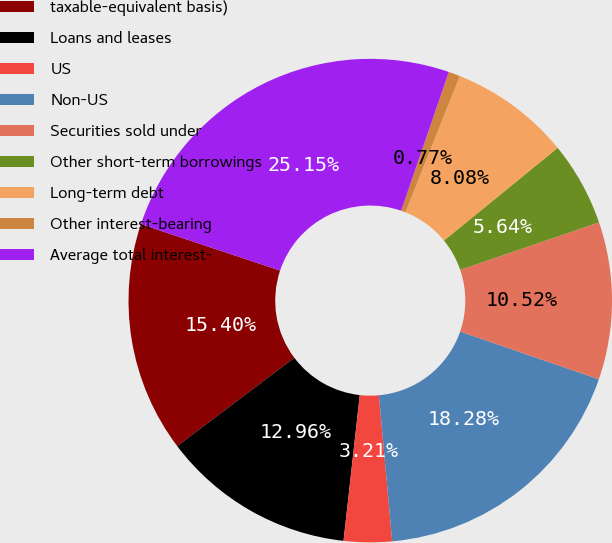<chart> <loc_0><loc_0><loc_500><loc_500><pie_chart><fcel>taxable-equivalent basis)<fcel>Loans and leases<fcel>US<fcel>Non-US<fcel>Securities sold under<fcel>Other short-term borrowings<fcel>Long-term debt<fcel>Other interest-bearing<fcel>Average total interest-<nl><fcel>15.4%<fcel>12.96%<fcel>3.21%<fcel>18.28%<fcel>10.52%<fcel>5.64%<fcel>8.08%<fcel>0.77%<fcel>25.15%<nl></chart> 